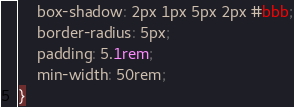<code> <loc_0><loc_0><loc_500><loc_500><_CSS_>    box-shadow: 2px 1px 5px 2px #bbb;
    border-radius: 5px;
    padding: 5.1rem;
    min-width: 50rem;    
}

</code> 